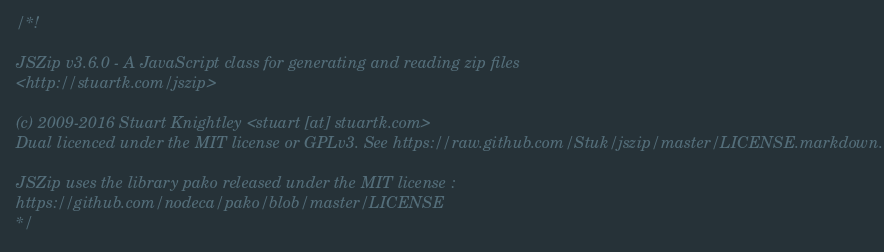<code> <loc_0><loc_0><loc_500><loc_500><_JavaScript_>/*!

JSZip v3.6.0 - A JavaScript class for generating and reading zip files
<http://stuartk.com/jszip>

(c) 2009-2016 Stuart Knightley <stuart [at] stuartk.com>
Dual licenced under the MIT license or GPLv3. See https://raw.github.com/Stuk/jszip/master/LICENSE.markdown.

JSZip uses the library pako released under the MIT license :
https://github.com/nodeca/pako/blob/master/LICENSE
*/
</code> 